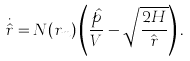<formula> <loc_0><loc_0><loc_500><loc_500>\dot { \hat { r } } = N ( r _ { m } ) \left ( \frac { \hat { p } } { V } - \sqrt { \frac { 2 H } { \hat { r } } } \right ) .</formula> 